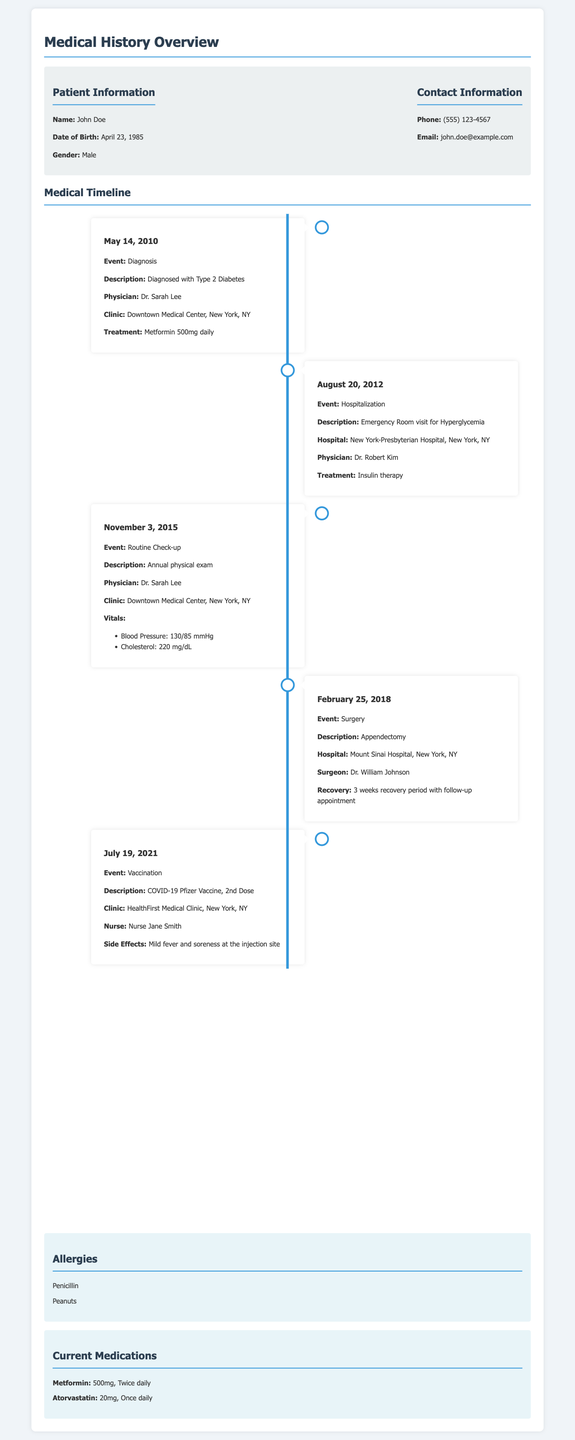What is the patient's name? The patient's name is listed in the document under patient information.
Answer: John Doe When was the patient diagnosed with Type 2 Diabetes? The diagnosis date is provided in the medical timeline section of the document.
Answer: May 14, 2010 Who performed the appendectomy? The surgeon's name is mentioned in the surgery entry of the timeline.
Answer: Dr. William Johnson What medication is prescribed twice daily? The current medications section lists the medications with their dosage and frequency.
Answer: Metformin What type of vaccine did the patient receive on July 19, 2021? The vaccination entry in the timeline specifies the type of vaccine received.
Answer: COVID-19 Pfizer Vaccine How many hospitalizations are listed in the timeline? The hospitalizations can be counted from the events described in the timeline section.
Answer: 1 What was the patient's blood pressure during the routine check-up? The patient's vitals are recorded in the routine check-up entry.
Answer: 130/85 mmHg What was the main treatment after the emergency room visit? The treatment is detailed in the hospitalization section of the timeline.
Answer: Insulin therapy How many allergies does the patient have listed? The number of allergies can be counted from the allergies section in the document.
Answer: 2 